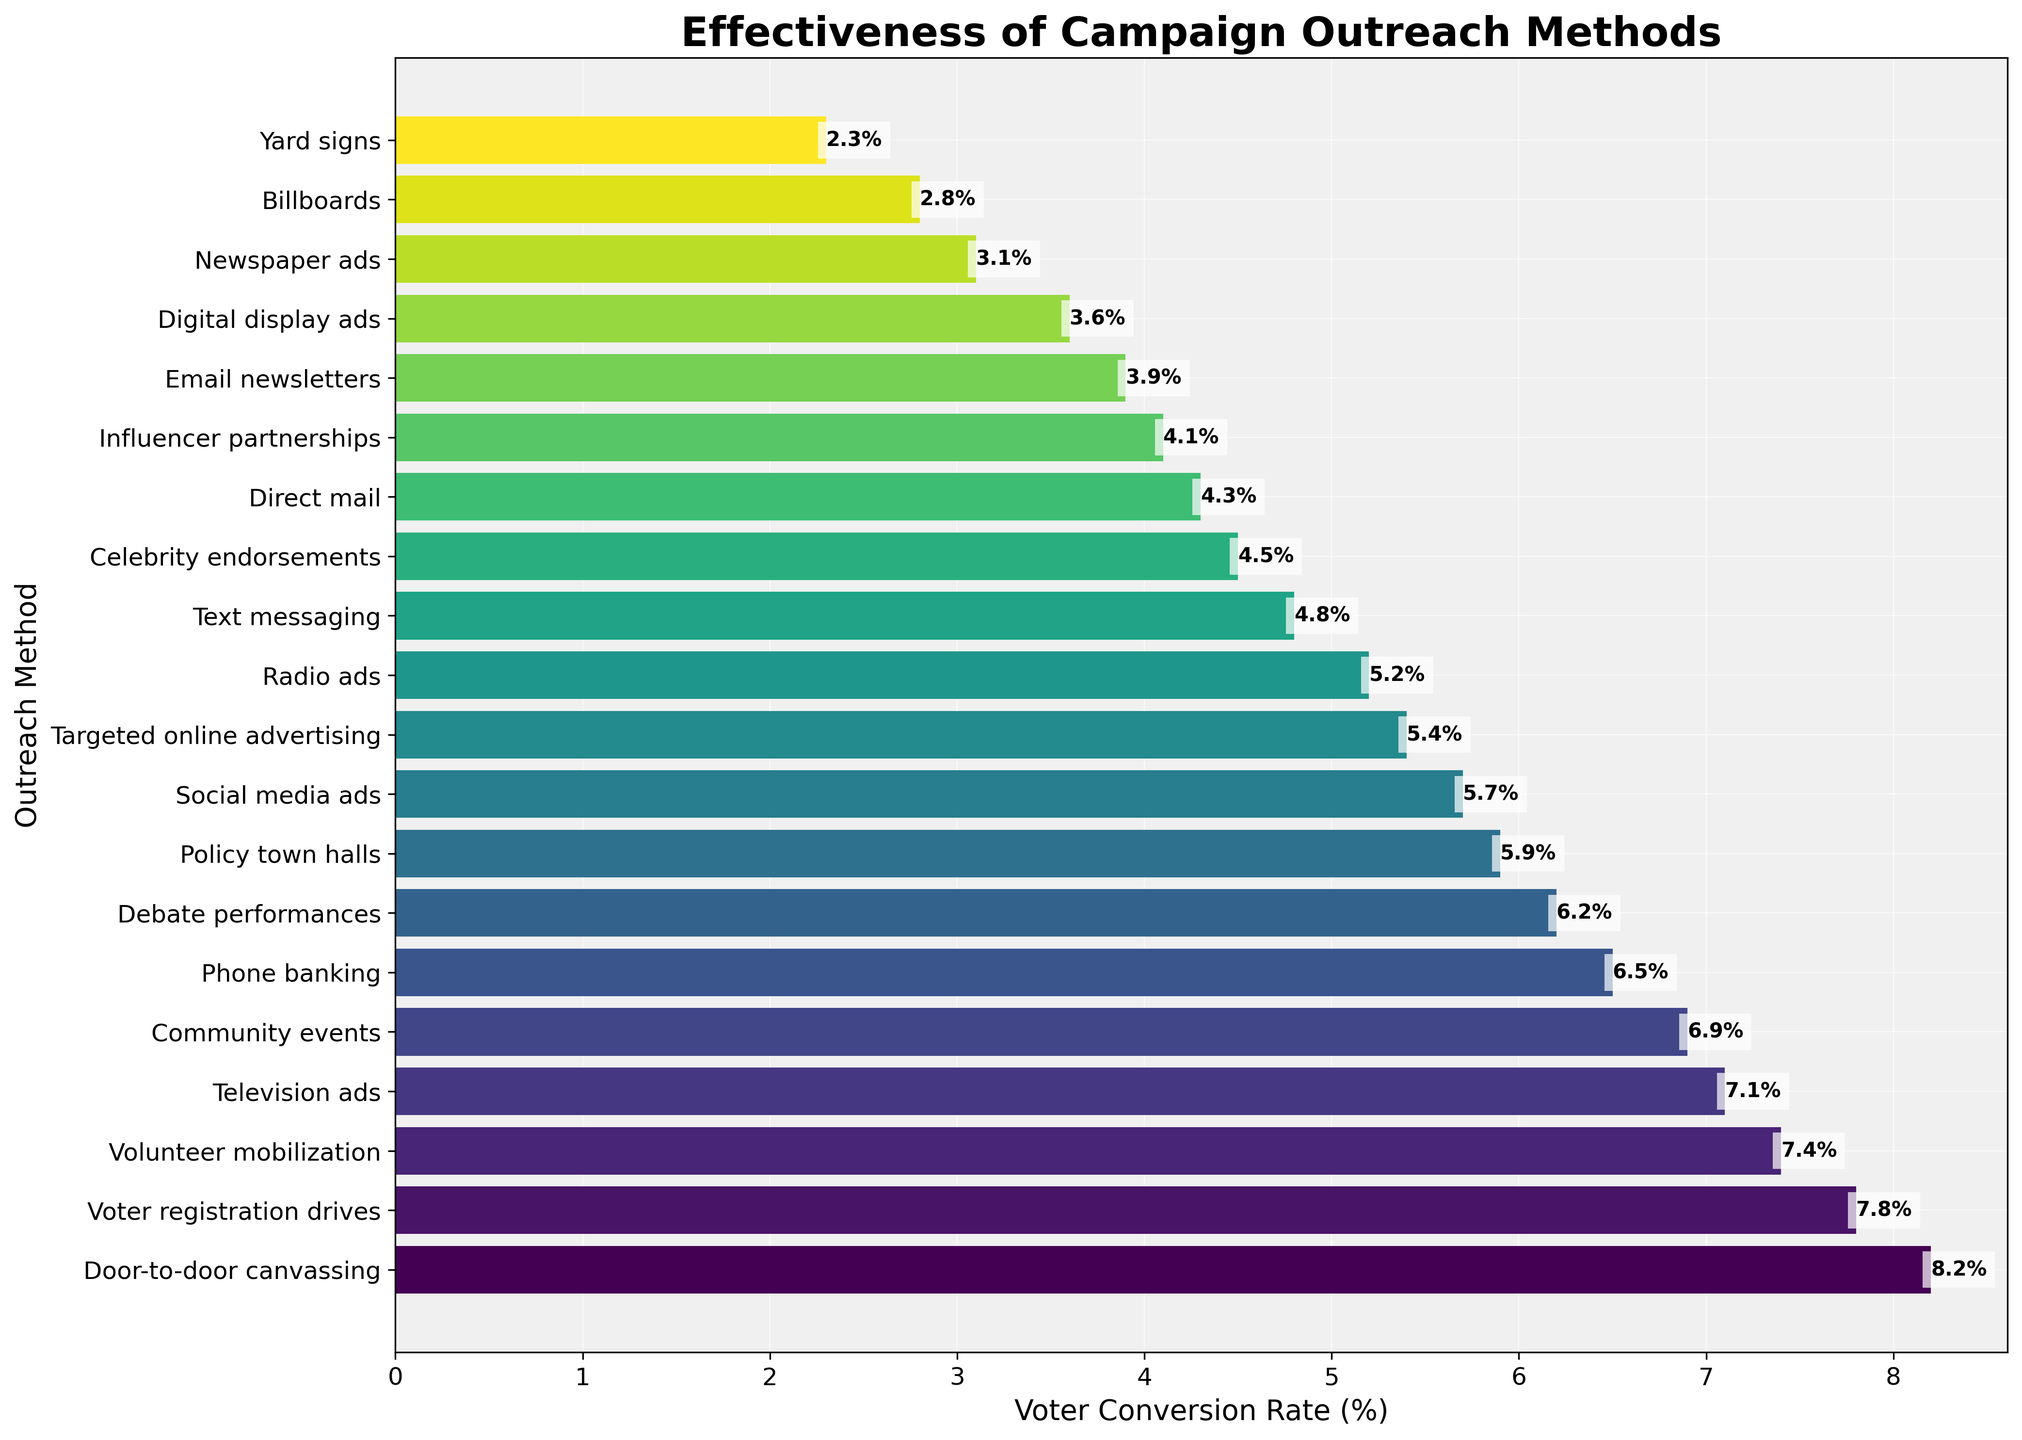What is the most effective campaign outreach method according to the data? The bar at the top of the figure represents the method with the highest voter conversion rate. The method listed next to the tallest bar is "Door-to-door canvassing" with a conversion rate of 8.2%.
Answer: Door-to-door canvassing Which outreach method has a higher conversion rate: Phone banking or Television ads? Look at the bars corresponding to "Phone banking" and "Television ads." Phone Banking has a conversion rate of 6.5%, and Television Ads has a conversion rate of 7.1%. Hence, Television Ads has a higher rate.
Answer: Television ads What is the combined conversion rate of Direct mail, Text messaging, and Newspaper ads? Add the conversion rates of "Direct mail" (4.3%), "Text messaging" (4.8%), and "Newspaper ads" (3.1%). 4.3 + 4.8 + 3.1 = 12.2.
Answer: 12.2% By how much does the conversion rate of Celebrity endorsements exceed Email newsletters? Subtract the conversion rate of "Email newsletters" (3.9%) from "Celebrity endorsements" (4.5%). 4.5 - 3.9 = 0.6.
Answer: 0.6% Which method has a lower conversion rate: Yard signs or Digital display ads? Compare the conversion rates: "Yard signs" has a conversion rate of 2.3%, and "Digital display ads" has a conversion rate of 3.6%. Yard signs have a lower conversion rate.
Answer: Yard signs What is the average conversion rate for Community events, Debate performances, and Policy town halls? Add the conversion rates of "Community events" (6.9%), "Debate performances" (6.2%), and "Policy town halls" (5.9%) and then divide by 3. (6.9 + 6.2 + 5.9) / 3 = 19 / 3 ≈ 6.33.
Answer: 6.33% Which two outreach methods have the closest conversion rates, and what are they? Identify the bars that have conversion rates closest to each other. "Influencer partnerships" (4.1%) and "Celebrity endorsements" (4.5%) are closest, with a difference of 0.4%.
Answer: Influencer partnerships and Celebrity endorsements Is the conversion rate of Social media ads greater than the median conversion rate of all methods? First, find the median conversion rate of all the methods by listing them in ascending order. The middle value (or the average of the two middle values) in the sorted list is the median. The social media ads rate is 5.7%. Comparing this to the median value, the median falls around methods like "Social media ads" or "Influencer partnerships," so 5.7% is right about at the median.
Answer: About equal What is the total conversion rate for methods with a conversion rate greater than 6%? Add conversion rates of methods with a rate greater than 6%. Summing up 8.2 (Door-to-door canvassing), 7.1 (Television ads), 6.5 (Phone banking), 6.9 (Community events), 7.8 (Voter registration drives), 7.4 (Volunteer mobilization), and 6.2 (Debate performances) gives: 8.2 + 7.1 + 6.5 + 6.9 + 7.8 + 7.4 + 6.2 = 50.1.
Answer: 50.1% Which campaign outreach method has the lowest voter conversion rate? The shortest bar in the figure corresponds to the method "Yard signs" with a conversion rate of 2.3%.
Answer: Yard signs 